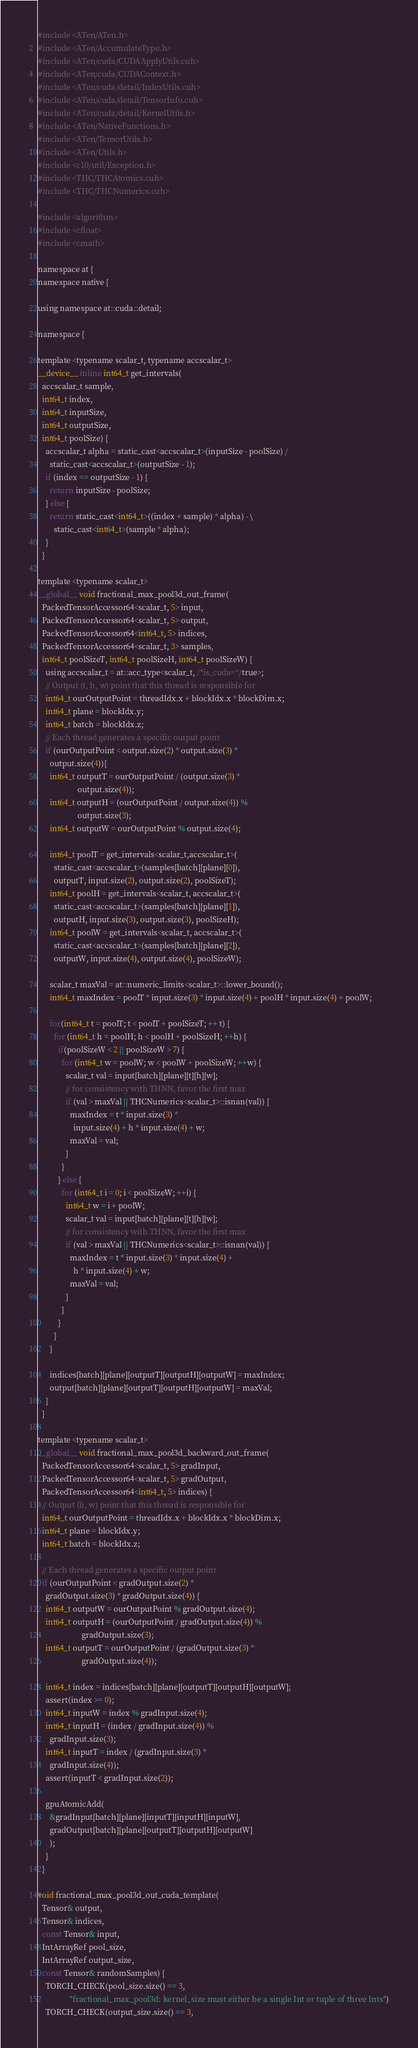<code> <loc_0><loc_0><loc_500><loc_500><_Cuda_>#include <ATen/ATen.h>
#include <ATen/AccumulateType.h>
#include <ATen/cuda/CUDAApplyUtils.cuh>
#include <ATen/cuda/CUDAContext.h>
#include <ATen/cuda/detail/IndexUtils.cuh>
#include <ATen/cuda/detail/TensorInfo.cuh>
#include <ATen/cuda/detail/KernelUtils.h>
#include <ATen/NativeFunctions.h>
#include <ATen/TensorUtils.h>
#include <ATen/Utils.h>
#include <c10/util/Exception.h>
#include <THC/THCAtomics.cuh>
#include <THC/THCNumerics.cuh>

#include <algorithm>
#include <cfloat>
#include <cmath>

namespace at {
namespace native {

using namespace at::cuda::detail;

namespace {

template <typename scalar_t, typename accscalar_t>
__device__ inline int64_t get_intervals(
  accscalar_t sample,
  int64_t index,
  int64_t inputSize,
  int64_t outputSize,
  int64_t poolSize) {
    accscalar_t alpha = static_cast<accscalar_t>(inputSize - poolSize) /
      static_cast<accscalar_t>(outputSize - 1);
    if (index == outputSize - 1) {
      return inputSize - poolSize;
    } else {
      return static_cast<int64_t>((index + sample) * alpha) - \
        static_cast<int64_t>(sample * alpha);
    }
  }

template <typename scalar_t>
__global__ void fractional_max_pool3d_out_frame(
  PackedTensorAccessor64<scalar_t, 5> input,
  PackedTensorAccessor64<scalar_t, 5> output,
  PackedTensorAccessor64<int64_t, 5> indices,
  PackedTensorAccessor64<scalar_t, 3> samples,
  int64_t poolSizeT, int64_t poolSizeH, int64_t poolSizeW) {
    using accscalar_t = at::acc_type<scalar_t, /*is_cuda=*/true>;
    // Output (t, h, w) point that this thread is responsible for
    int64_t ourOutputPoint = threadIdx.x + blockIdx.x * blockDim.x;
    int64_t plane = blockIdx.y;
    int64_t batch = blockIdx.z;
    // Each thread generates a specific output point
    if (ourOutputPoint < output.size(2) * output.size(3) *
      output.size(4)){
      int64_t outputT = ourOutputPoint / (output.size(3) *
                    output.size(4));
      int64_t outputH = (ourOutputPoint / output.size(4)) %
                    output.size(3);
      int64_t outputW = ourOutputPoint % output.size(4);

      int64_t poolT = get_intervals<scalar_t,accscalar_t>(
        static_cast<accscalar_t>(samples[batch][plane][0]),
        outputT, input.size(2), output.size(2), poolSizeT);
      int64_t poolH = get_intervals<scalar_t, accscalar_t>(
        static_cast<accscalar_t>(samples[batch][plane][1]),
        outputH, input.size(3), output.size(3), poolSizeH);
      int64_t poolW = get_intervals<scalar_t, accscalar_t>(
        static_cast<accscalar_t>(samples[batch][plane][2]),
        outputW, input.size(4), output.size(4), poolSizeW);

      scalar_t maxVal = at::numeric_limits<scalar_t>::lower_bound();
      int64_t maxIndex = poolT * input.size(3) * input.size(4) + poolH * input.size(4) + poolW;

      for(int64_t t = poolT; t < poolT + poolSizeT; ++ t) {
        for (int64_t h = poolH; h < poolH + poolSizeH; ++h) {
          if(poolSizeW < 2 || poolSizeW > 7) {
            for (int64_t w = poolW; w < poolW + poolSizeW; ++w) {
              scalar_t val = input[batch][plane][t][h][w];
              // for consistency with THNN, favor the first max
              if (val > maxVal || THCNumerics<scalar_t>::isnan(val)) {
                maxIndex = t * input.size(3) *
                  input.size(4) + h * input.size(4) + w;
                maxVal = val;
              }
            }
          } else {
            for (int64_t i = 0; i < poolSizeW; ++i) {
              int64_t w = i + poolW;
              scalar_t val = input[batch][plane][t][h][w];
              // for consistency with THNN, favor the first max
              if (val > maxVal || THCNumerics<scalar_t>::isnan(val)) {
                maxIndex = t * input.size(3) * input.size(4) +
                  h * input.size(4) + w;
                maxVal = val;
              }
            }
          }
        }
      }

      indices[batch][plane][outputT][outputH][outputW] = maxIndex;
      output[batch][plane][outputT][outputH][outputW] = maxVal;
    }
  }

template <typename scalar_t>
__global__ void fractional_max_pool3d_backward_out_frame(
  PackedTensorAccessor64<scalar_t, 5> gradInput,
  PackedTensorAccessor64<scalar_t, 5> gradOutput,
  PackedTensorAccessor64<int64_t, 5> indices) {
  // Output (h, w) point that this thread is responsible for
  int64_t ourOutputPoint = threadIdx.x + blockIdx.x * blockDim.x;
  int64_t plane = blockIdx.y;
  int64_t batch = blockIdx.z;

  // Each thread generates a specific output point
  if (ourOutputPoint < gradOutput.size(2) *
    gradOutput.size(3) * gradOutput.size(4)) {
    int64_t outputW = ourOutputPoint % gradOutput.size(4);
    int64_t outputH = (ourOutputPoint / gradOutput.size(4)) %
                      gradOutput.size(3);
    int64_t outputT = ourOutputPoint / (gradOutput.size(3) *
                      gradOutput.size(4));

    int64_t index = indices[batch][plane][outputT][outputH][outputW];
    assert(index >= 0);
    int64_t inputW = index % gradInput.size(4);
    int64_t inputH = (index / gradInput.size(4)) %
      gradInput.size(3);
    int64_t inputT = index / (gradInput.size(3) *
      gradInput.size(4));
    assert(inputT < gradInput.size(2));

    gpuAtomicAdd(
      &gradInput[batch][plane][inputT][inputH][inputW],
      gradOutput[batch][plane][outputT][outputH][outputW]
      );
    }
  }

void fractional_max_pool3d_out_cuda_template(
  Tensor& output,
  Tensor& indices,
  const Tensor& input,
  IntArrayRef pool_size,
  IntArrayRef output_size,
  const Tensor& randomSamples) {
    TORCH_CHECK(pool_size.size() == 3,
                "fractional_max_pool3d: kernel_size must either be a single Int or tuple of three Ints")
    TORCH_CHECK(output_size.size() == 3,</code> 